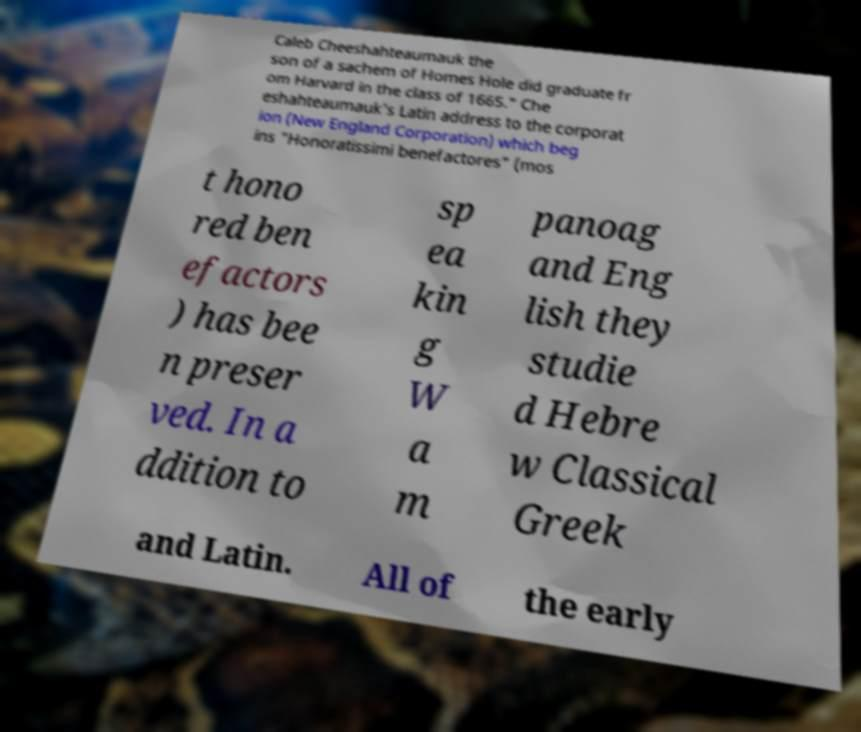Could you extract and type out the text from this image? Caleb Cheeshahteaumauk the son of a sachem of Homes Hole did graduate fr om Harvard in the class of 1665." Che eshahteaumauk's Latin address to the corporat ion (New England Corporation) which beg ins "Honoratissimi benefactores" (mos t hono red ben efactors ) has bee n preser ved. In a ddition to sp ea kin g W a m panoag and Eng lish they studie d Hebre w Classical Greek and Latin. All of the early 